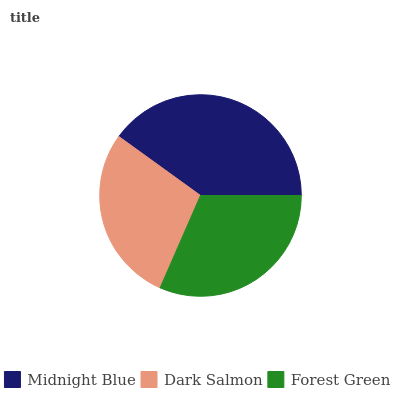Is Dark Salmon the minimum?
Answer yes or no. Yes. Is Midnight Blue the maximum?
Answer yes or no. Yes. Is Forest Green the minimum?
Answer yes or no. No. Is Forest Green the maximum?
Answer yes or no. No. Is Forest Green greater than Dark Salmon?
Answer yes or no. Yes. Is Dark Salmon less than Forest Green?
Answer yes or no. Yes. Is Dark Salmon greater than Forest Green?
Answer yes or no. No. Is Forest Green less than Dark Salmon?
Answer yes or no. No. Is Forest Green the high median?
Answer yes or no. Yes. Is Forest Green the low median?
Answer yes or no. Yes. Is Midnight Blue the high median?
Answer yes or no. No. Is Dark Salmon the low median?
Answer yes or no. No. 